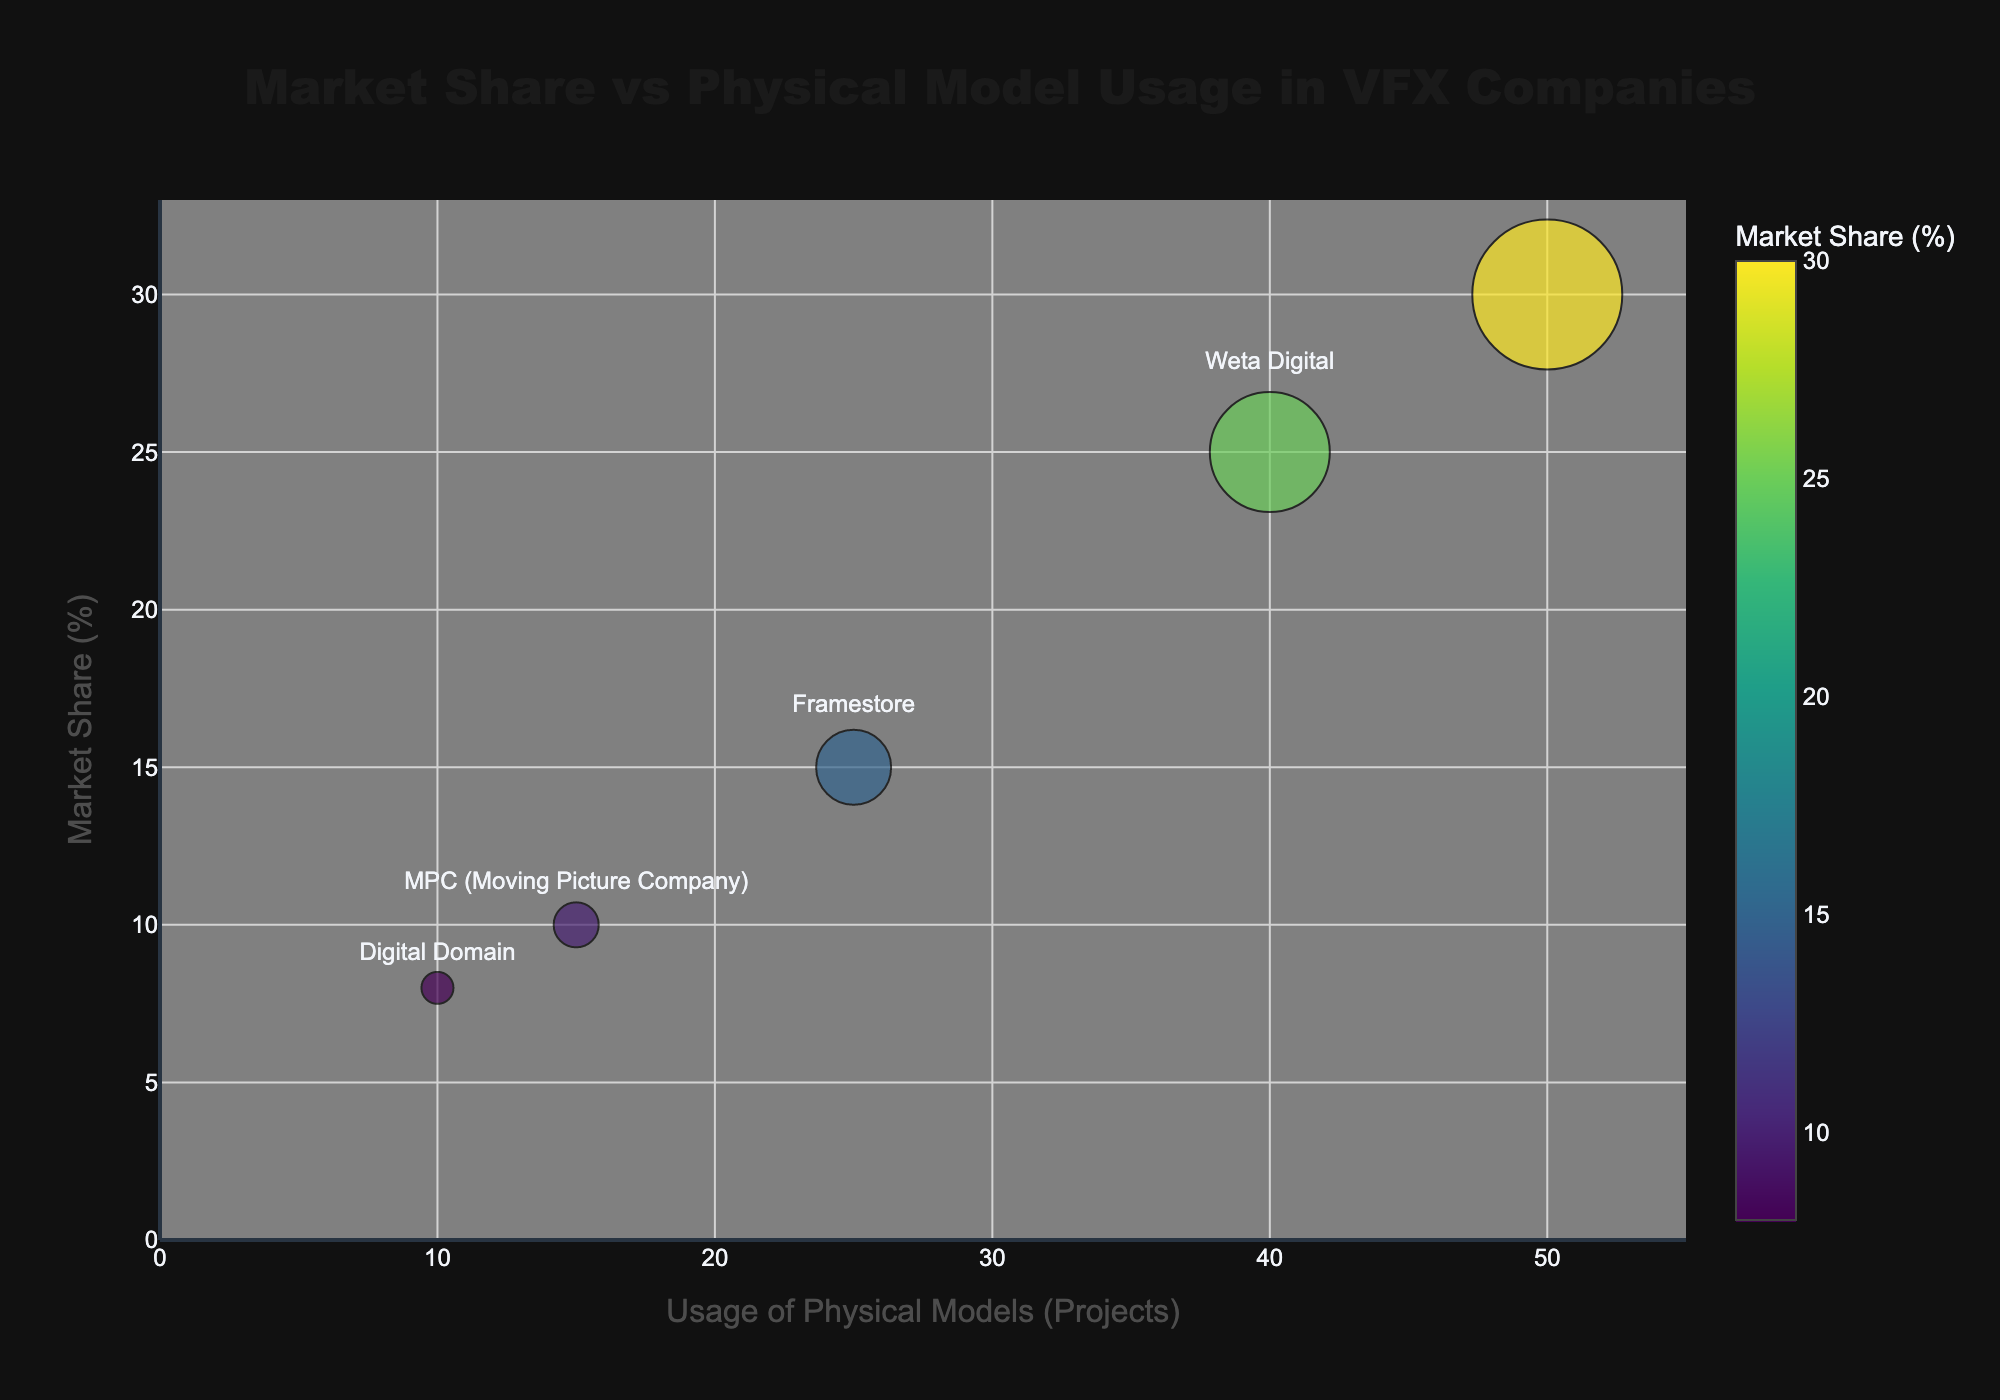What's the title of the bubble chart? The title of the chart is usually positioned at the top and is an immediate element to identify. Here, the title "Market Share vs Physical Model Usage in VFX Companies" is clearly visible at the top center.
Answer: Market Share vs Physical Model Usage in VFX Companies How many companies are represented in the bubble chart? To determine the number of companies, count the distinct bubbles or data points in the chart. Each bubble represents one company. There are five bubbles, indicating five companies.
Answer: 5 Which company has the highest market share and what is its value? Look for the bubble positioned highest on the y-axis, which measures market share. The highest bubble is labeled "Industrial Light & Magic (ILM)" with a market share of 30%.
Answer: Industrial Light & Magic (ILM), 30% What is the range of the x-axis in the bubble chart? The x-axis represents the usage of physical models. The range can be observed by looking at the axis' start and end values. The x-axis ranges from 0 to approximately 55 projects.
Answer: 0 to 55 projects Which company uses the most physical models and how many projects do they use them in? Examine the bubbles along the x-axis to find the one farthest to the right. "Industrial Light & Magic (ILM)" is the farthest, using physical models in 50 projects.
Answer: Industrial Light & Magic (ILM), 50 projects What is the average market share percentage of all the companies? Sum the market share values of all companies and divide by the number of companies. (30% + 25% + 15% + 10% + 8%) / 5 = 88% / 5 = 17.6%.
Answer: 17.6% Which two companies have the smallest difference in market share, and what is that difference? Compare the market shares of all pairs and find the smallest difference. "MPC" and "Digital Domain" have market shares of 10% and 8%, respectively, yielding a difference of 10% - 8% = 2%.
Answer: MPC and Digital Domain, 2% Which company has the largest bubble and what does the bubble size represent? Observe the bubbles to find the largest one, which belongs to "Industrial Light & Magic (ILM)." The bubble size is 1500, representing its significance or weight in the chart, though the exact metric isn't specified in detail.
Answer: Industrial Light & Magic (ILM), Bubble Size represents significance/weight Is there a company with both a market share above 20% and usage of physical models below 45 projects? If so, which one? Look for bubbles that meet both conditions: market share above 20% (y-axis) and physical model usage below 45 projects (x-axis). "Weta Digital" fits these criteria with 25% market share and 40 projects.
Answer: Weta Digital Compare the market share and physical model usage between Framestore and MPC. Which one has higher market share and higher physical model usage? Examine the positions of "Framestore" and "MPC" bubbles. "Framestore" has a higher market share of 15% compared to MPC's 10%, and also higher physical model usage with 25 projects versus MPC's 15 projects.
Answer: Framestore, Framestore 